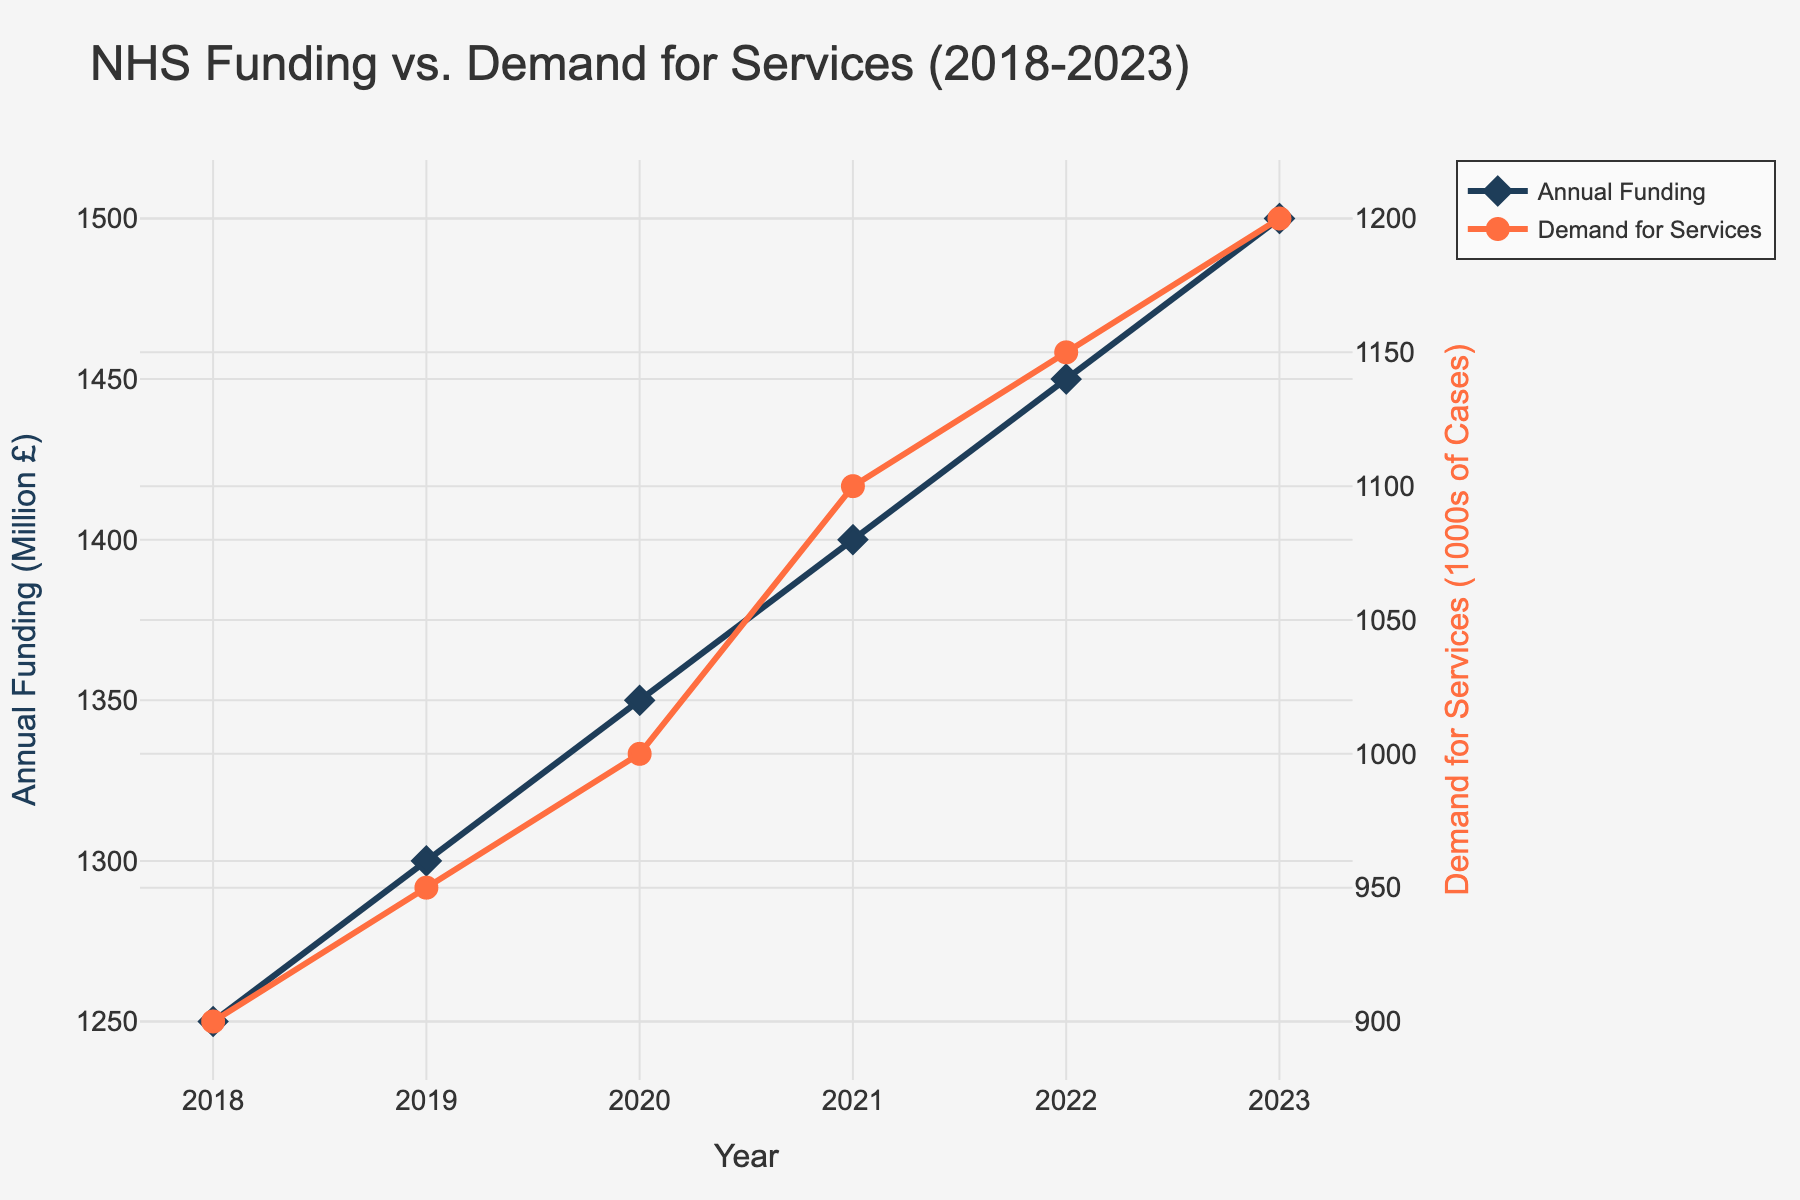What is the title of the plot? The title of the plot appears at the top of the figure and gives an overview of what the plot is representing.
Answer: NHS Funding vs. Demand for Services (2018-2023) How many years of data are displayed in the plot? Count the number of data points or entries on the x-axis (Year). There are six years listed (from 2018 to 2023).
Answer: 6 Which year shows the highest demand for services? Look for the highest data point on the 'Demand for Services (in 1000s of Cases)' line, and trace it back to the corresponding year on the x-axis.
Answer: 2023 By how much did the annual funding increase from 2018 to 2023? Subtract the annual funding value for 2018 from that for 2023. According to the data: 1500 million £ (2023) - 1250 million £ (2018).
Answer: 250 million £ What has a steeper trend, the increase in funding or the increase in demand for services? Observe the slopes of both lines over the years. The steeper trend indicates a quicker rise.
Answer: Increase in demand for services How much did the demand for services increase each year on average? Calculate the average yearly increase by subtracting the initial demand from the final demand and dividing by the number of years minus 1. (1200 - 900) / (2023 - 2018).
Answer: 60 (1000s of cases/year) In which year did the annual funding see the smallest increase compared to the previous year? Compare the annual increases between consecutive years and identify the smallest difference.
Answer: 2019 (50 million £) What was the difference in demand for services between 2021 and 2022? Find the demand values for 2021 and 2022 and subtract the former from the latter (1150 - 1100).
Answer: 50 (1000s of cases) Did the demand for services ever decrease from one year to the next? Observe the line representing demand for services for any downward trend. The line continually rises, indicating no decrease.
Answer: No What were the annual funding and demand for services values in 2020? Identify the data points associated with the year 2020. Annual funding: 1350 million £, Demand for Services: 1000 (1000s of Cases).
Answer: 1350 million £ & 1000 (1000s of Cases) 